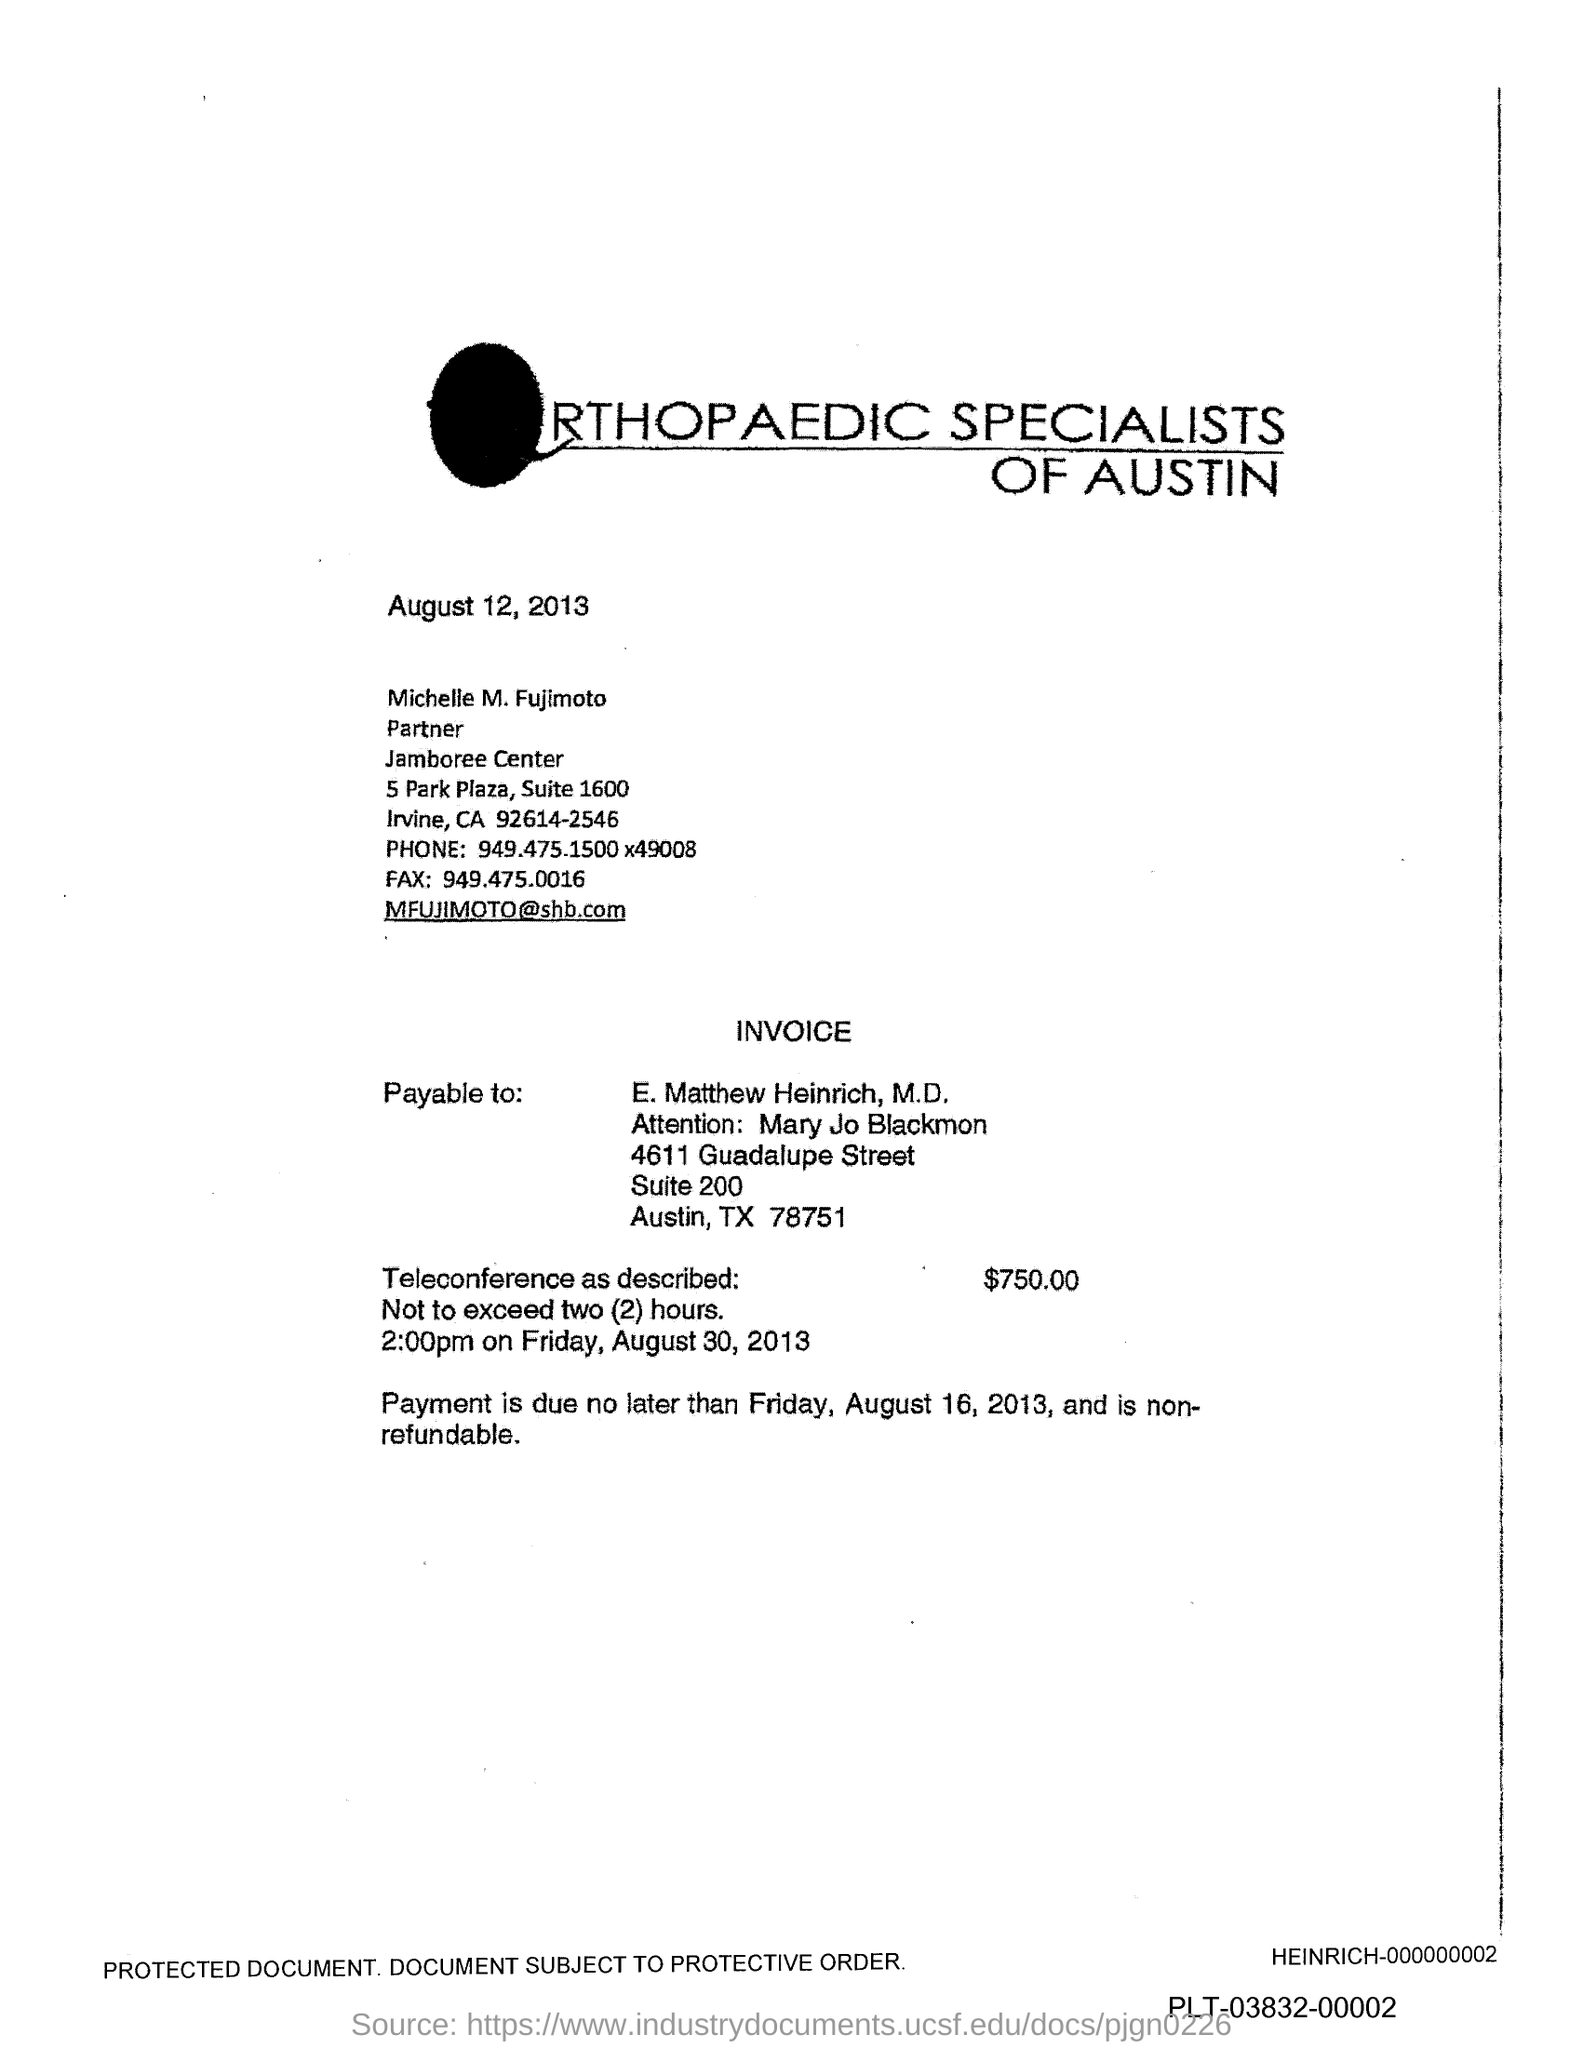Point out several critical features in this image. The phone number mentioned in the document is 949.475.1500 followed by the digit 49008. The fax number is 949.475.0016. 